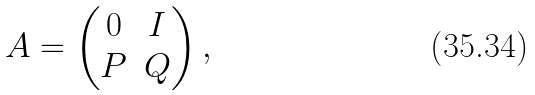Convert formula to latex. <formula><loc_0><loc_0><loc_500><loc_500>A = \begin{pmatrix} 0 & I \\ P & Q \end{pmatrix} ,</formula> 